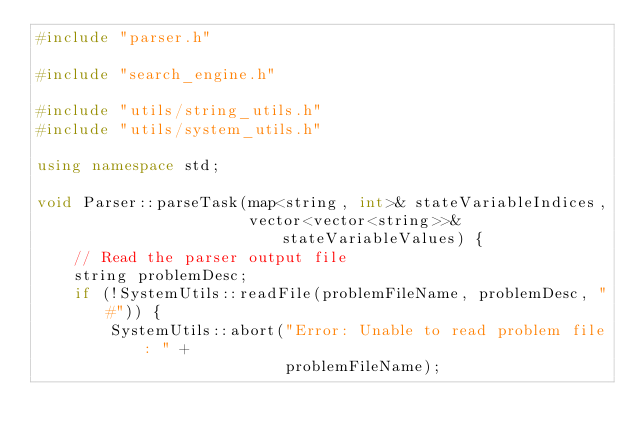<code> <loc_0><loc_0><loc_500><loc_500><_C++_>#include "parser.h"

#include "search_engine.h"

#include "utils/string_utils.h"
#include "utils/system_utils.h"

using namespace std;

void Parser::parseTask(map<string, int>& stateVariableIndices,
                       vector<vector<string>>& stateVariableValues) {
    // Read the parser output file
    string problemDesc;
    if (!SystemUtils::readFile(problemFileName, problemDesc, "#")) {
        SystemUtils::abort("Error: Unable to read problem file: " +
                           problemFileName);</code> 